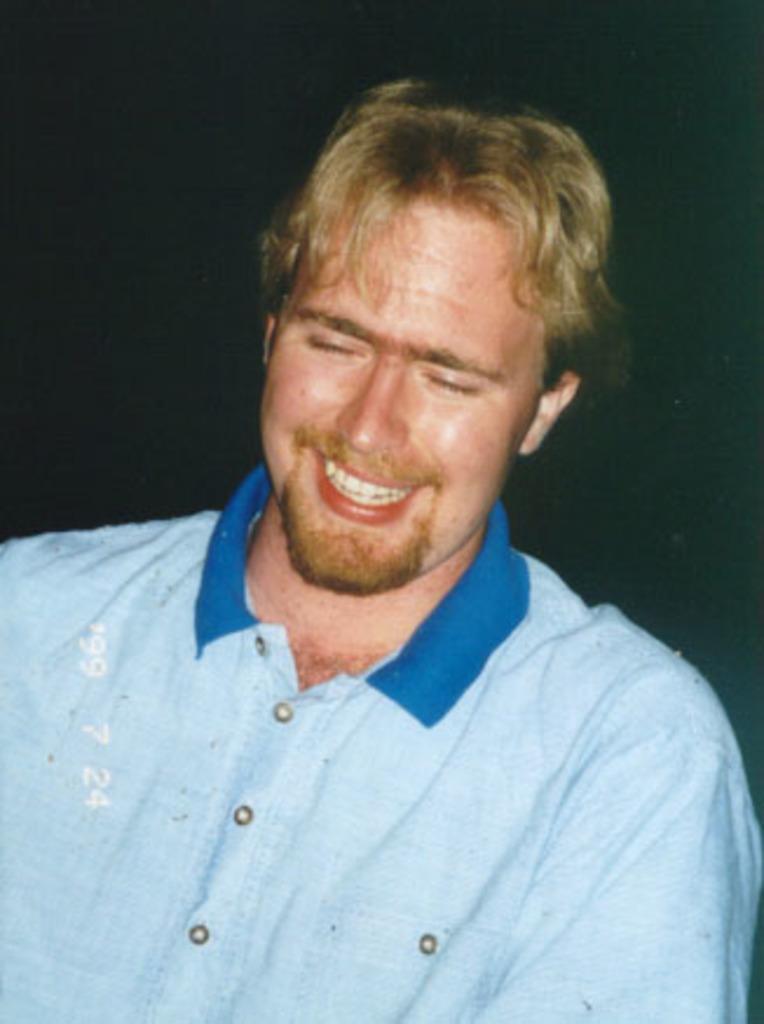Describe this image in one or two sentences. In this image the background is dark. In the middle of the image there is a man with a smiling face. He has worn a blue T-shirt. 